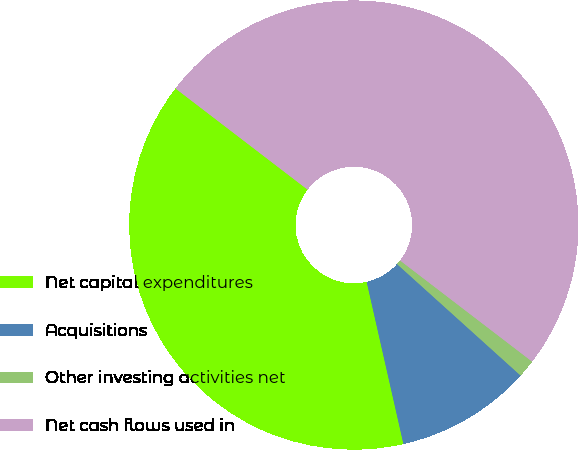<chart> <loc_0><loc_0><loc_500><loc_500><pie_chart><fcel>Net capital expenditures<fcel>Acquisitions<fcel>Other investing activities net<fcel>Net cash flows used in<nl><fcel>38.95%<fcel>9.77%<fcel>1.28%<fcel>50.0%<nl></chart> 